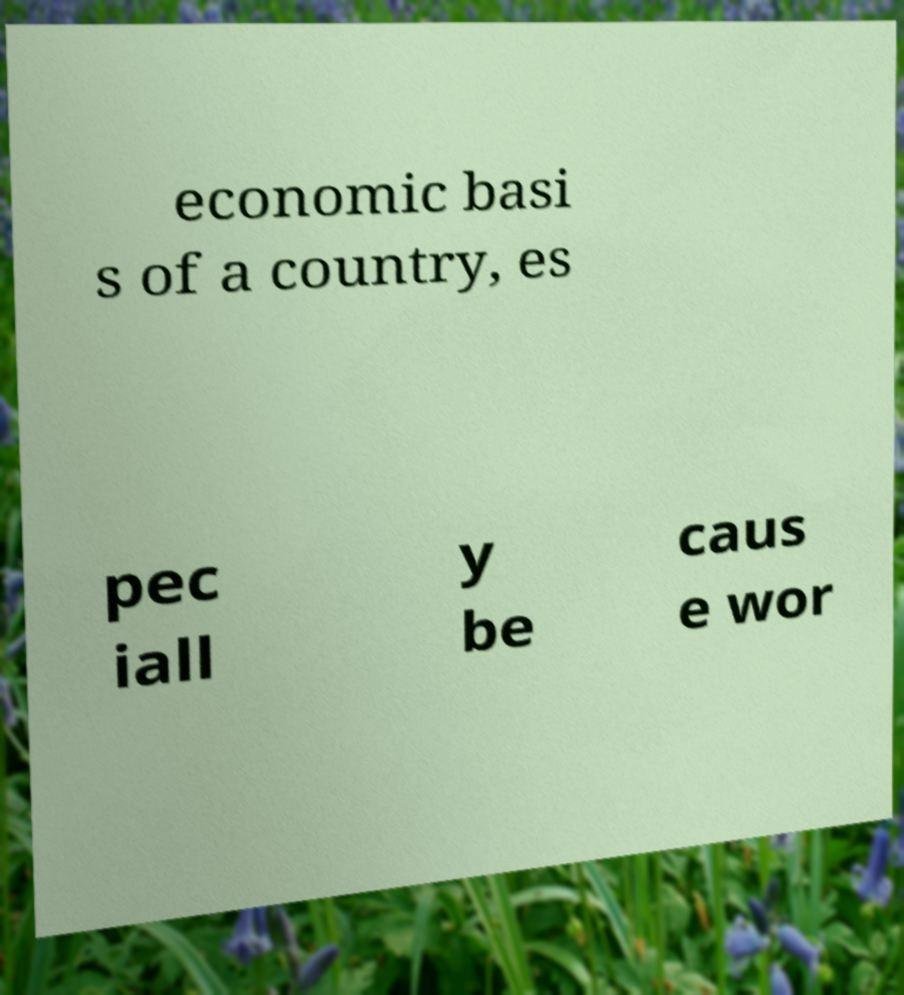Can you read and provide the text displayed in the image?This photo seems to have some interesting text. Can you extract and type it out for me? economic basi s of a country, es pec iall y be caus e wor 